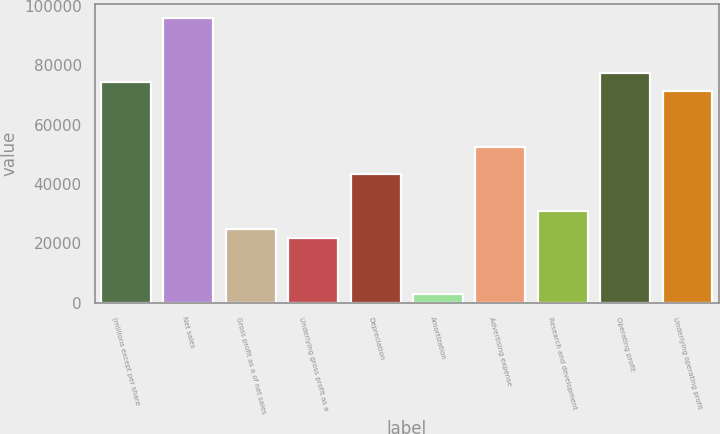<chart> <loc_0><loc_0><loc_500><loc_500><bar_chart><fcel>(millions except per share<fcel>Net sales<fcel>Gross profit as a of net sales<fcel>Underlying gross profit as a<fcel>Depreciation<fcel>Amortization<fcel>Advertising expense<fcel>Research and development<fcel>Operating profit<fcel>Underlying operating profit<nl><fcel>74275.7<fcel>95939<fcel>24759.5<fcel>21664.8<fcel>43328.1<fcel>3096.19<fcel>52612.3<fcel>30949<fcel>77370.4<fcel>71180.9<nl></chart> 